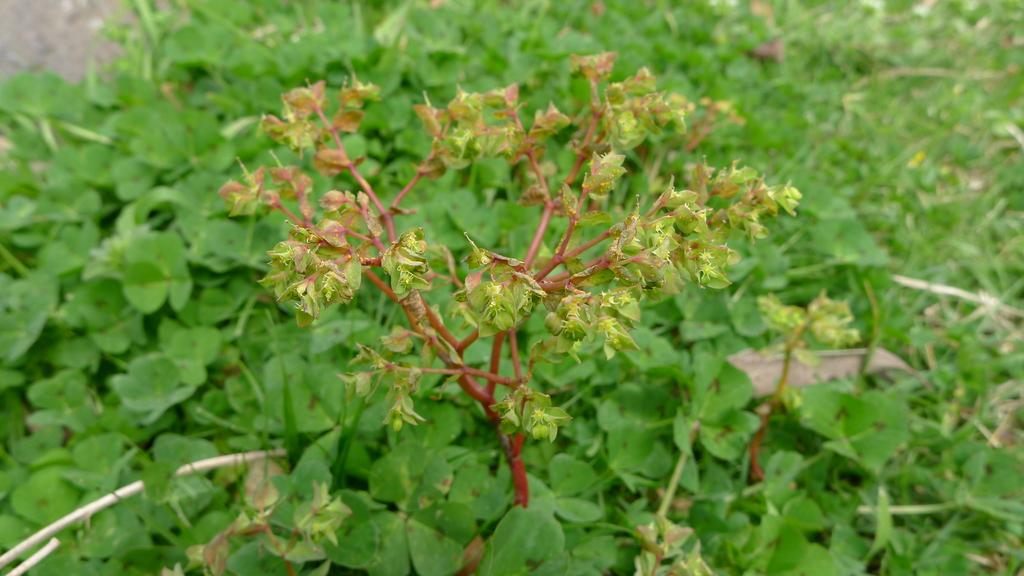What is the main subject in the center of the image? There is a plant in the center of the image. What can be seen in the background of the image? There is greenery in the background of the image. What type of harbor can be seen in the image? There is no harbor present in the image; it features a plant and greenery in the background. What emotion does the plant appear to be experiencing in the image? Plants do not experience emotions, so it is not possible to determine the emotion of the plant in the image. 